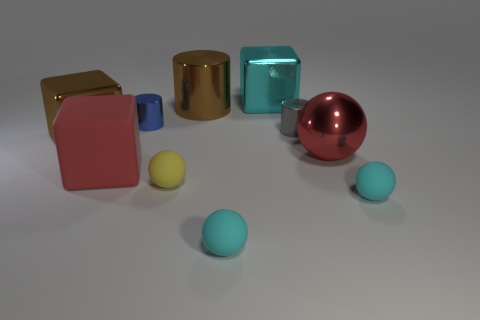What number of other objects are there of the same color as the big cylinder?
Your answer should be compact. 1. How big is the red thing that is left of the tiny cylinder behind the small gray object?
Ensure brevity in your answer.  Large. Does the tiny cyan sphere to the right of the red sphere have the same material as the big cyan block?
Your answer should be very brief. No. There is a red thing that is to the right of the red rubber cube; what is its shape?
Ensure brevity in your answer.  Sphere. What number of red things have the same size as the rubber cube?
Ensure brevity in your answer.  1. The shiny sphere has what size?
Your answer should be very brief. Large. What number of large blocks are in front of the large red metal object?
Make the answer very short. 1. The blue thing that is made of the same material as the red sphere is what shape?
Give a very brief answer. Cylinder. Is the number of cyan metallic things to the right of the small gray cylinder less than the number of cyan objects that are behind the red rubber block?
Your answer should be very brief. Yes. Are there more large red spheres than yellow cubes?
Your answer should be very brief. Yes. 